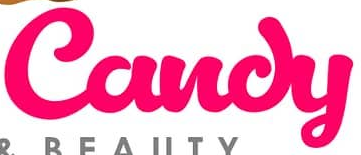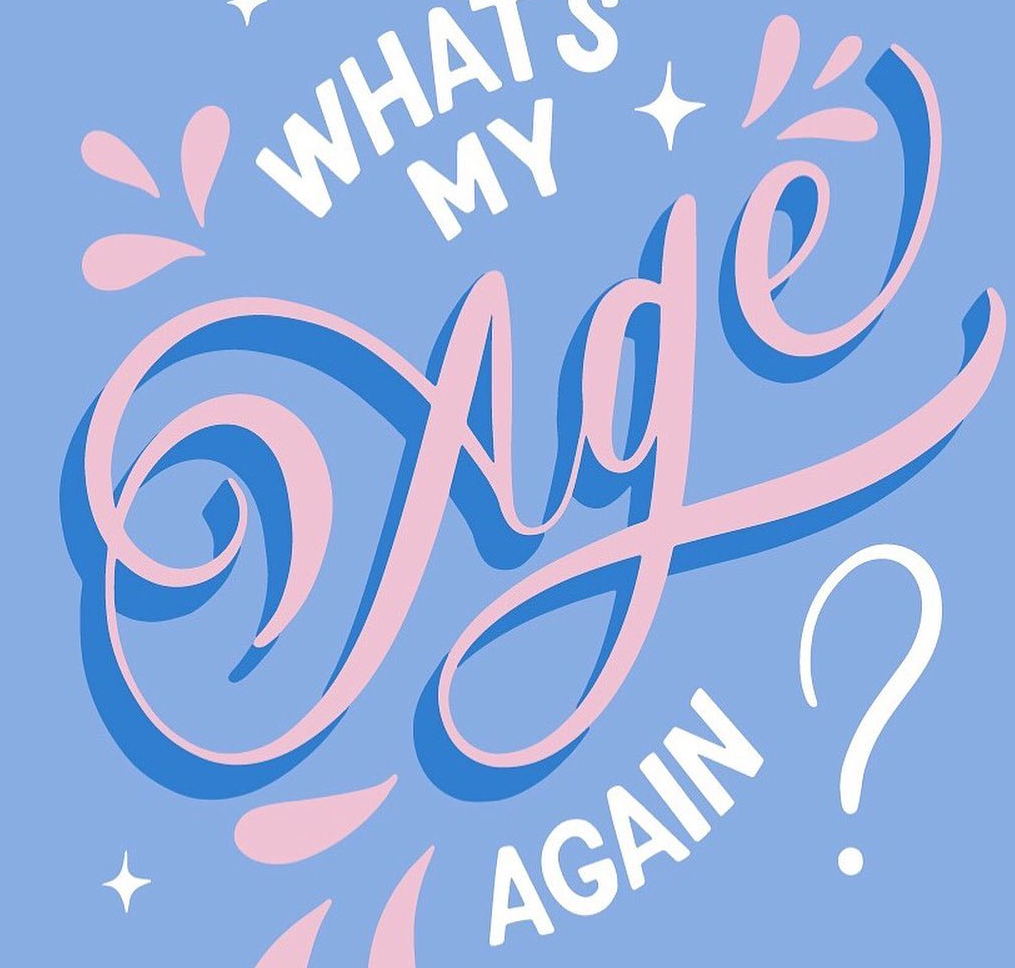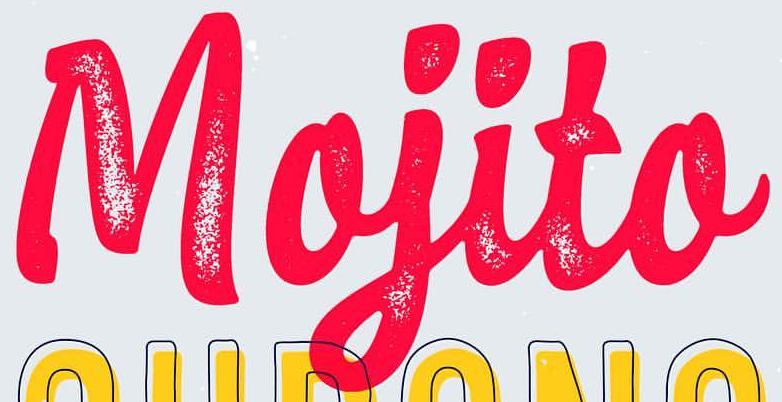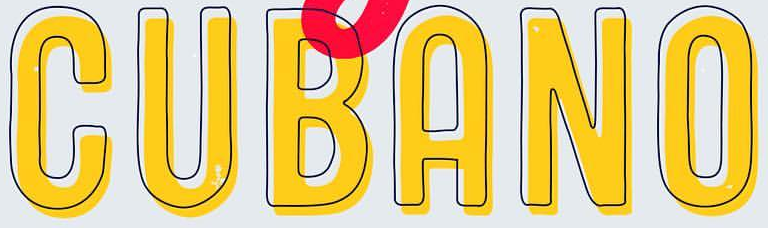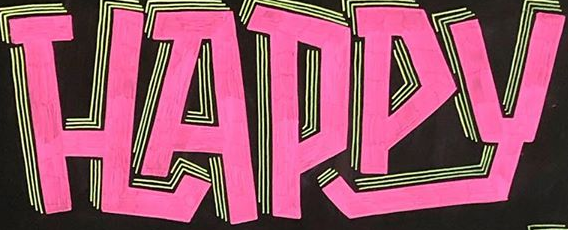Transcribe the words shown in these images in order, separated by a semicolon. Candy; Age; Mojito; CUBANO; HAPPY 